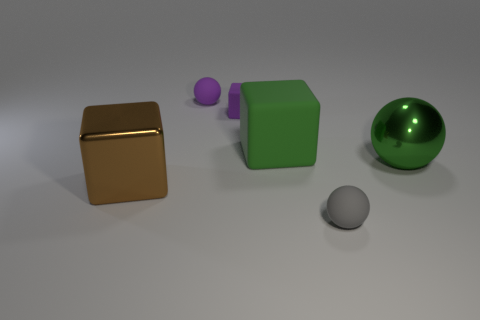Add 2 large green shiny balls. How many objects exist? 8 Add 2 green shiny objects. How many green shiny objects are left? 3 Add 6 tiny purple shiny balls. How many tiny purple shiny balls exist? 6 Subtract 1 gray spheres. How many objects are left? 5 Subtract all small brown metallic objects. Subtract all green metallic things. How many objects are left? 5 